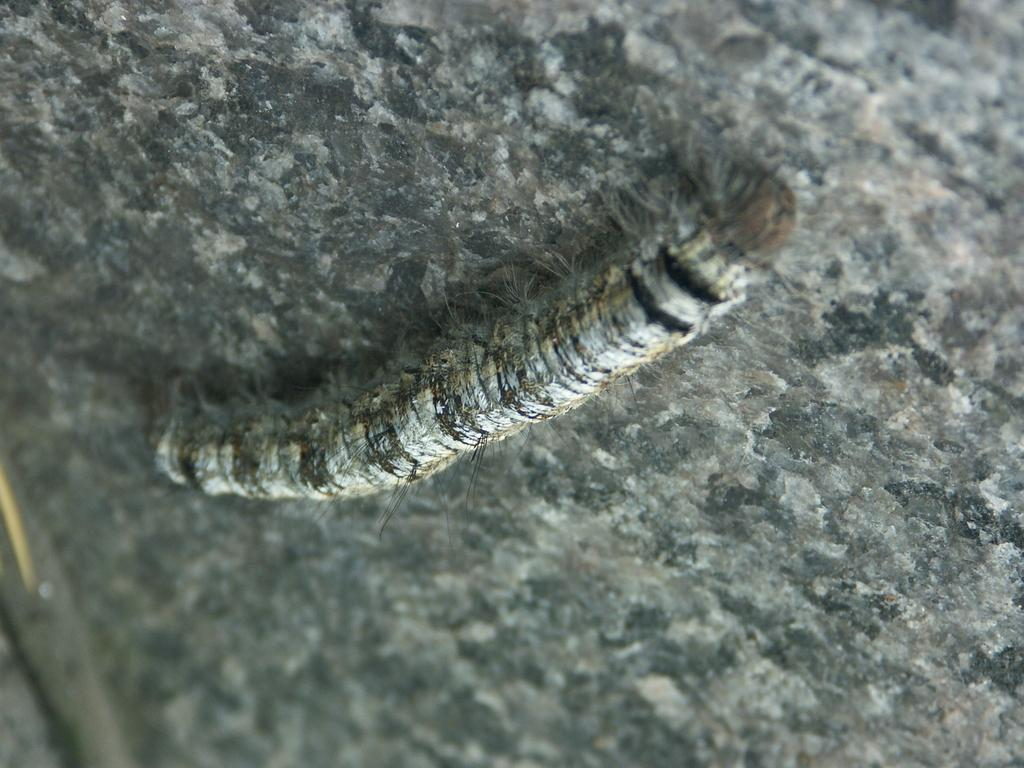What is the main subject in the foreground of the image? There is an insect in the foreground of the image. Where is the insect located? The insect is on a surface. How many sheep are visible in the image? There are no sheep present in the image. What type of hair can be seen on the insect in the image? Insects do not have hair, and there is no hair visible in the image. 